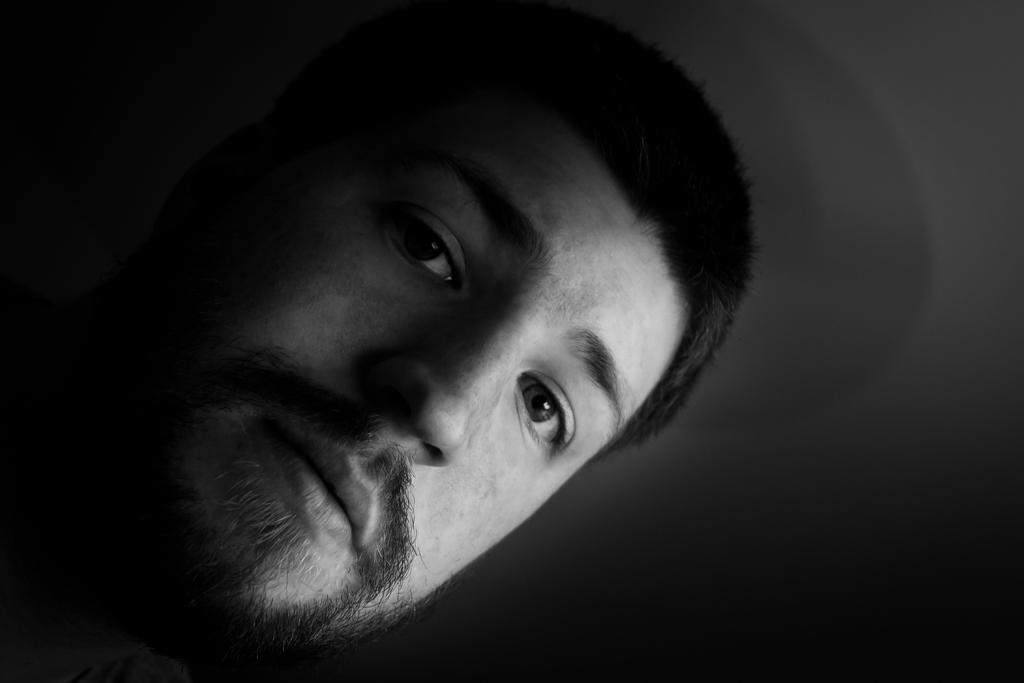Can you describe this image briefly? It is a black and white picture. In the center of the image we can see one human face. 